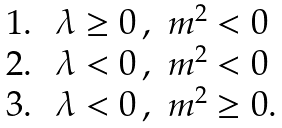<formula> <loc_0><loc_0><loc_500><loc_500>\begin{array} [ p o s ] { l l l } 1 . \, & \lambda \geq 0 \, , & m ^ { 2 } < 0 \\ 2 . \, & \lambda < 0 \, , & m ^ { 2 } < 0 \\ 3 . \, & \lambda < 0 \, , & m ^ { 2 } \geq 0 . \end{array}</formula> 